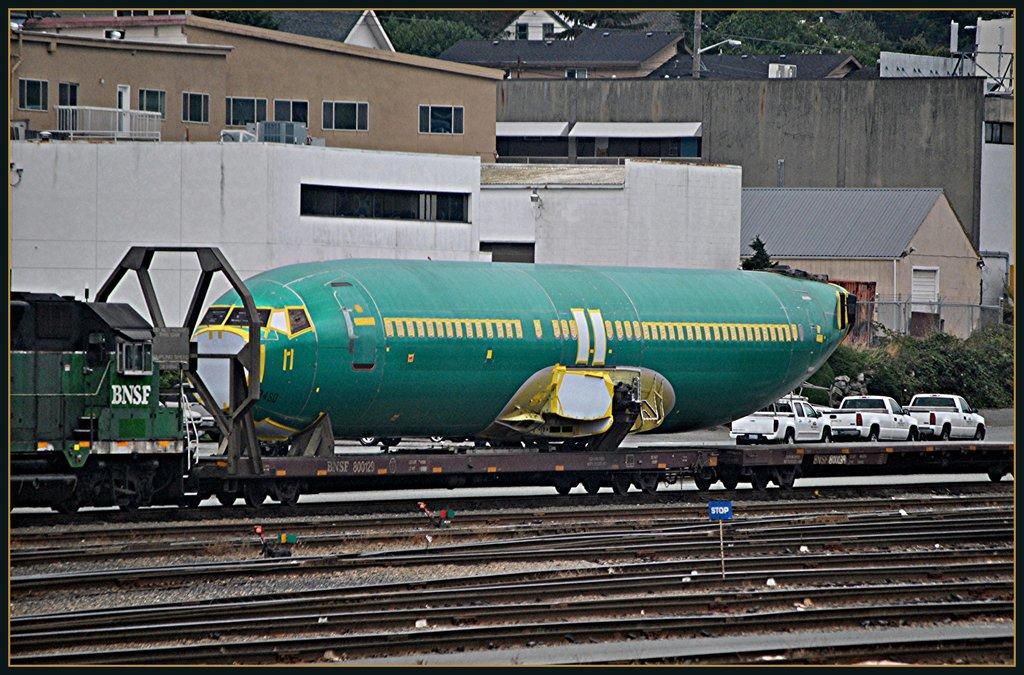Can you describe this image briefly? Here in this picture we can see an aircraft present on the trolley of a train, which is present on the track and in the front we can see an engine present and beside that also we can see other number of tracks present on the ground and in the far we can see cars present on the road and we can see buildings and houses with number of windows present over there and we can also see plants and trees present. 